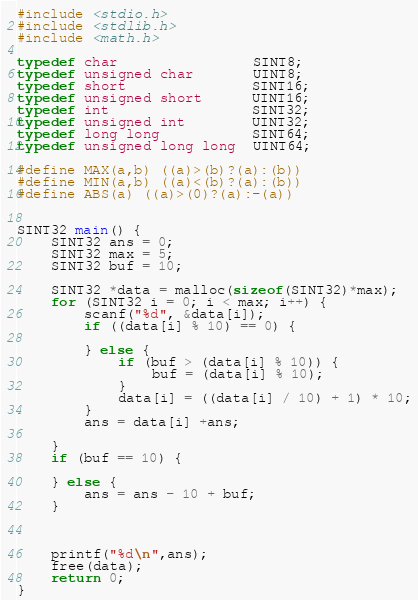<code> <loc_0><loc_0><loc_500><loc_500><_C_>#include <stdio.h>
#include <stdlib.h>
#include <math.h>

typedef char                SINT8;
typedef unsigned char       UINT8;
typedef short               SINT16;
typedef unsigned short      UINT16;
typedef int                 SINT32;
typedef unsigned int        UINT32;
typedef long long           SINT64;
typedef unsigned long long  UINT64;

#define MAX(a,b) ((a)>(b)?(a):(b))
#define MIN(a,b) ((a)<(b)?(a):(b))
#define ABS(a) ((a)>(0)?(a):-(a))


SINT32 main() {
    SINT32 ans = 0;
    SINT32 max = 5;
    SINT32 buf = 10;
    
    SINT32 *data = malloc(sizeof(SINT32)*max);
    for (SINT32 i = 0; i < max; i++) {
        scanf("%d", &data[i]);
        if ((data[i] % 10) == 0) {

        } else {
            if (buf > (data[i] % 10)) {
                buf = (data[i] % 10);
            }
            data[i] = ((data[i] / 10) + 1) * 10;
        }
        ans = data[i] +ans;

    }
    if (buf == 10) {

    } else {
        ans = ans - 10 + buf;
    }

    

    printf("%d\n",ans);
    free(data);
	return 0;
}</code> 